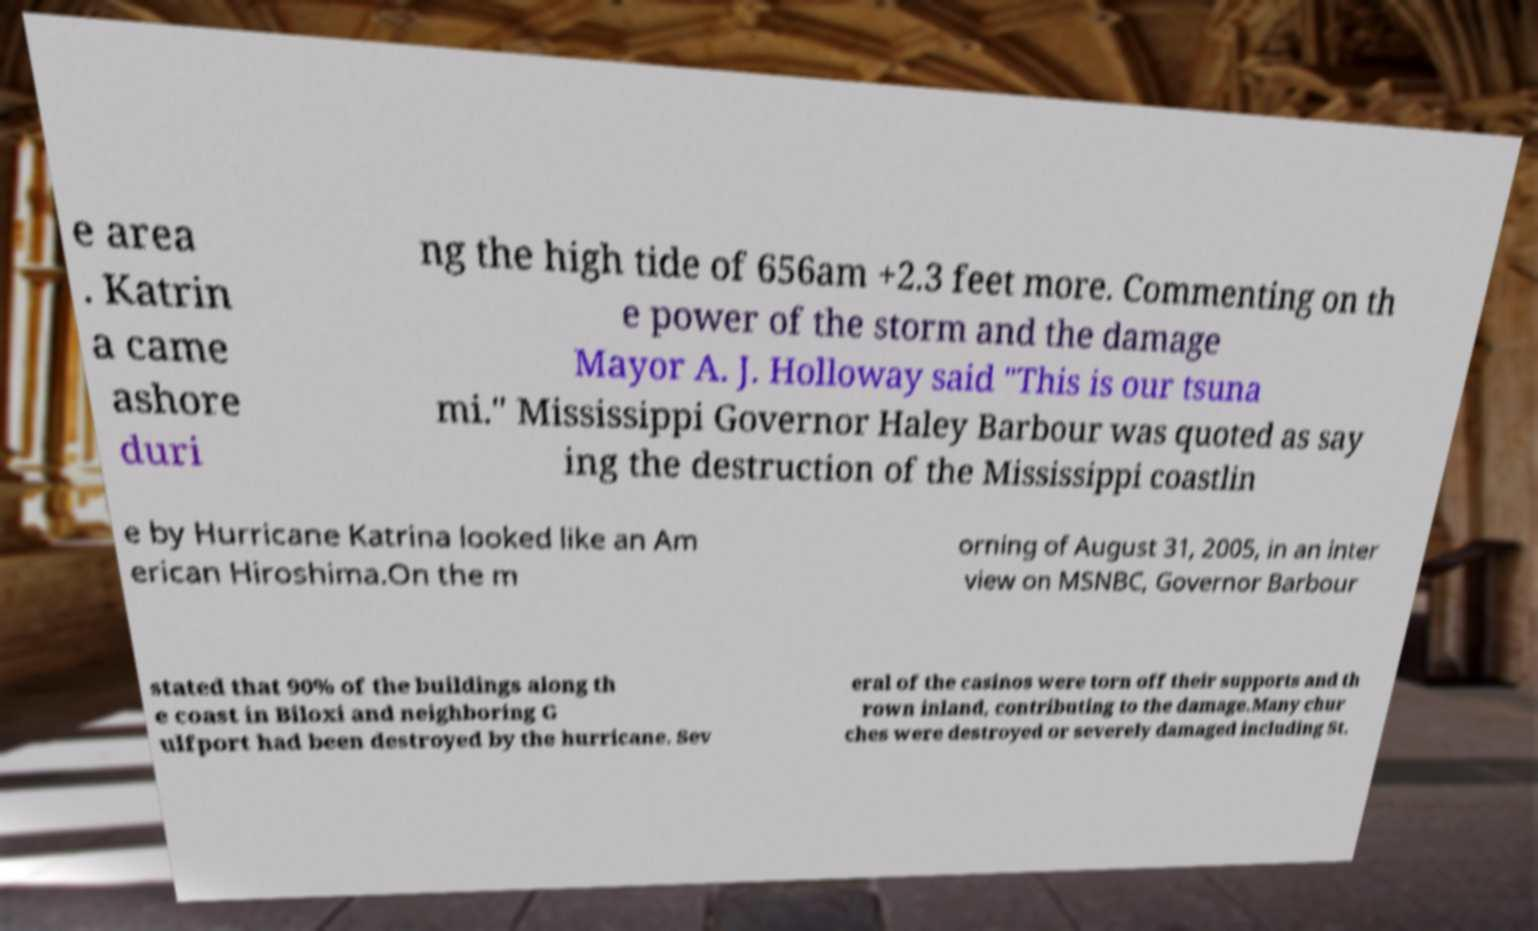I need the written content from this picture converted into text. Can you do that? e area . Katrin a came ashore duri ng the high tide of 656am +2.3 feet more. Commenting on th e power of the storm and the damage Mayor A. J. Holloway said "This is our tsuna mi." Mississippi Governor Haley Barbour was quoted as say ing the destruction of the Mississippi coastlin e by Hurricane Katrina looked like an Am erican Hiroshima.On the m orning of August 31, 2005, in an inter view on MSNBC, Governor Barbour stated that 90% of the buildings along th e coast in Biloxi and neighboring G ulfport had been destroyed by the hurricane. Sev eral of the casinos were torn off their supports and th rown inland, contributing to the damage.Many chur ches were destroyed or severely damaged including St. 